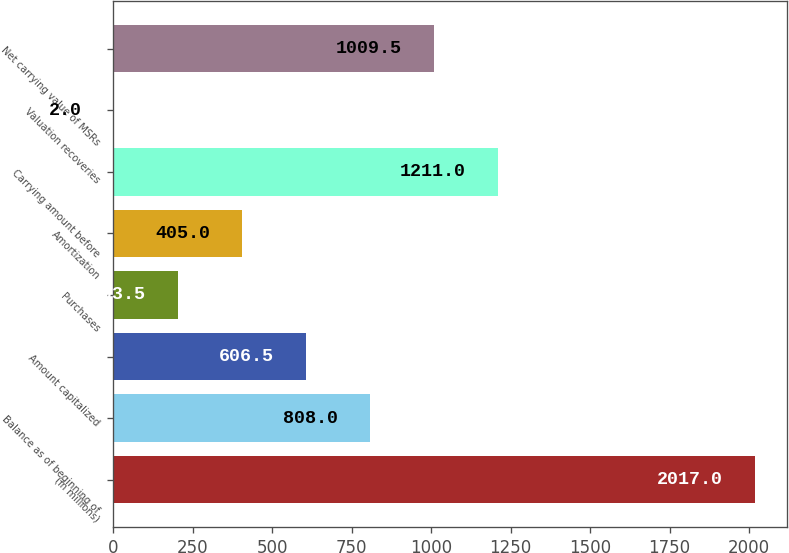Convert chart. <chart><loc_0><loc_0><loc_500><loc_500><bar_chart><fcel>(in millions)<fcel>Balance as of beginning of<fcel>Amount capitalized<fcel>Purchases<fcel>Amortization<fcel>Carrying amount before<fcel>Valuation recoveries<fcel>Net carrying value of MSRs<nl><fcel>2017<fcel>808<fcel>606.5<fcel>203.5<fcel>405<fcel>1211<fcel>2<fcel>1009.5<nl></chart> 